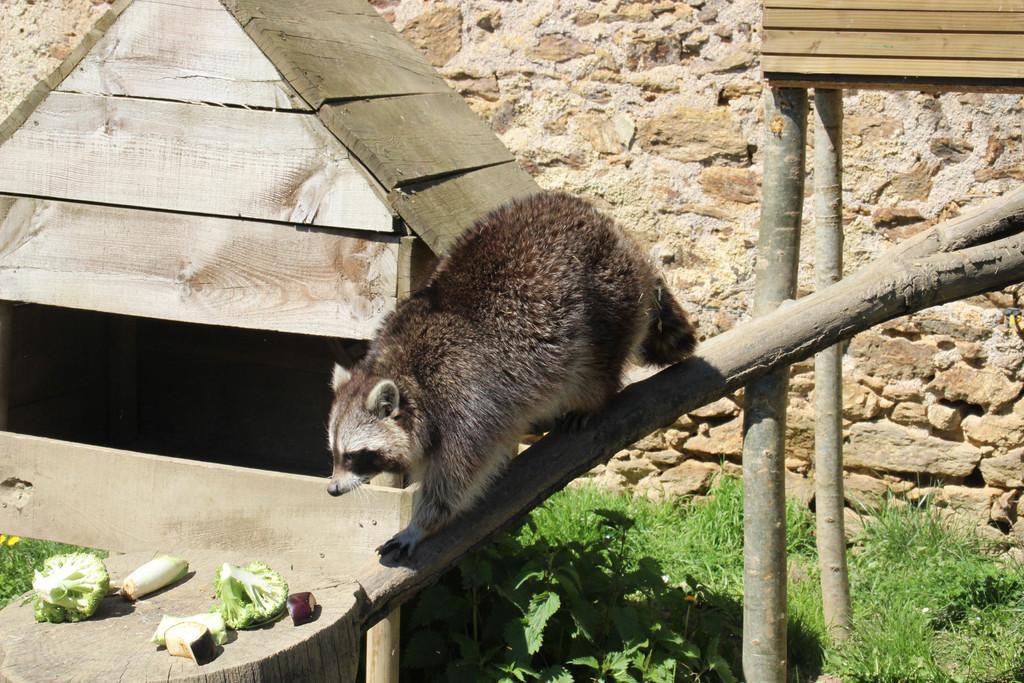How would you summarize this image in a sentence or two? In this picture I can see there is a raccoon walking on the trunk of a tree and there are some vegetables placed here at left and there is a wooden house in the backdrop and there are small plants, grass on the floor and there is a wall in the backdrop. 